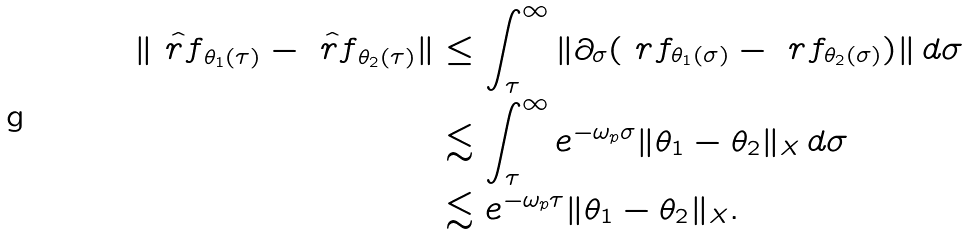Convert formula to latex. <formula><loc_0><loc_0><loc_500><loc_500>\| \hat { \ r f } _ { \theta _ { 1 } ( \tau ) } - \hat { \ r f } _ { \theta _ { 2 } ( \tau ) } \| & \leq \int _ { \tau } ^ { \infty } \| \partial _ { \sigma } ( \ r f _ { \theta _ { 1 } ( \sigma ) } - \ r f _ { \theta _ { 2 } ( \sigma ) } ) \| \, d \sigma \\ & \lesssim \int _ { \tau } ^ { \infty } e ^ { - \omega _ { p } \sigma } \| \theta _ { 1 } - \theta _ { 2 } \| _ { X } \, d \sigma \\ & \lesssim e ^ { - \omega _ { p } \tau } \| \theta _ { 1 } - \theta _ { 2 } \| _ { X } .</formula> 